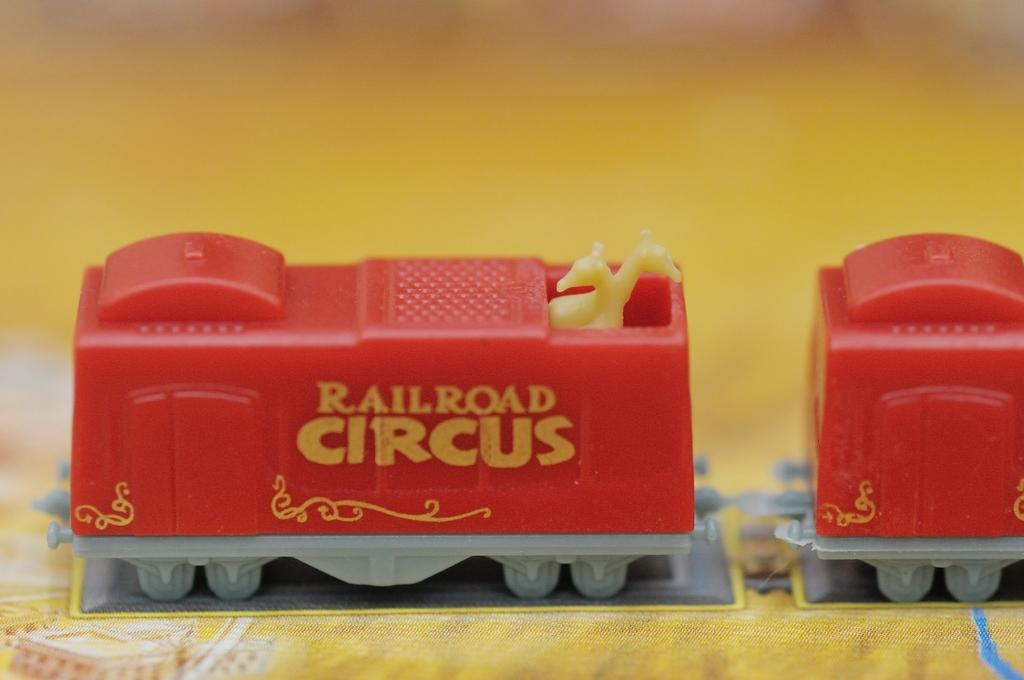What type of toy is present in the image? There are legos in the image. What is located at the bottom of the image? There is a cloth at the bottom of the image. What type of music can be heard playing in the background of the image? There is no music present in the image, as it only features legos and a cloth. 